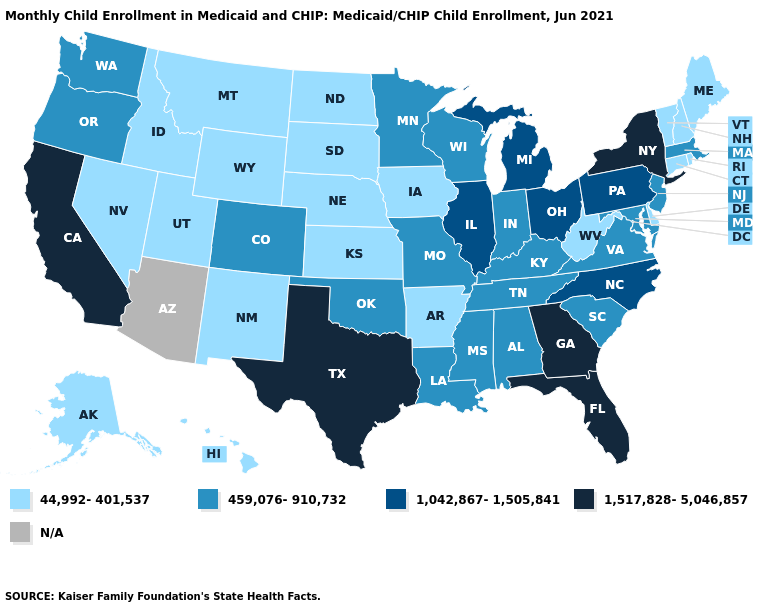Name the states that have a value in the range 44,992-401,537?
Answer briefly. Alaska, Arkansas, Connecticut, Delaware, Hawaii, Idaho, Iowa, Kansas, Maine, Montana, Nebraska, Nevada, New Hampshire, New Mexico, North Dakota, Rhode Island, South Dakota, Utah, Vermont, West Virginia, Wyoming. What is the highest value in the USA?
Write a very short answer. 1,517,828-5,046,857. Which states have the lowest value in the South?
Be succinct. Arkansas, Delaware, West Virginia. Does Michigan have the lowest value in the USA?
Write a very short answer. No. Name the states that have a value in the range 1,517,828-5,046,857?
Write a very short answer. California, Florida, Georgia, New York, Texas. What is the value of Idaho?
Write a very short answer. 44,992-401,537. What is the highest value in the USA?
Quick response, please. 1,517,828-5,046,857. Name the states that have a value in the range 1,042,867-1,505,841?
Short answer required. Illinois, Michigan, North Carolina, Ohio, Pennsylvania. Among the states that border Massachusetts , does New York have the highest value?
Answer briefly. Yes. What is the lowest value in the Northeast?
Answer briefly. 44,992-401,537. Name the states that have a value in the range 44,992-401,537?
Keep it brief. Alaska, Arkansas, Connecticut, Delaware, Hawaii, Idaho, Iowa, Kansas, Maine, Montana, Nebraska, Nevada, New Hampshire, New Mexico, North Dakota, Rhode Island, South Dakota, Utah, Vermont, West Virginia, Wyoming. Does the map have missing data?
Answer briefly. Yes. What is the value of Maryland?
Write a very short answer. 459,076-910,732. 